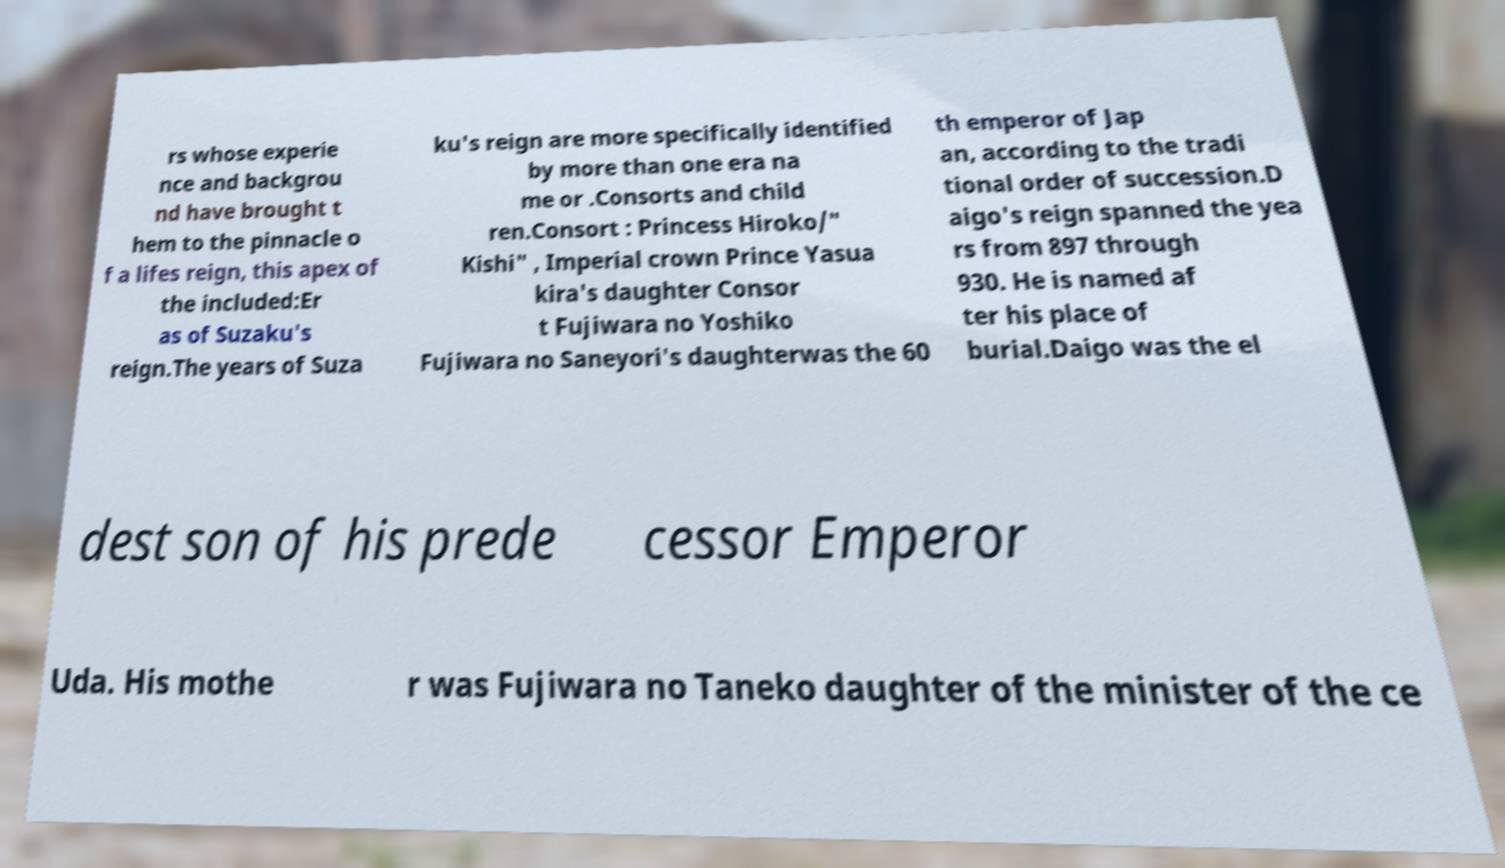Could you assist in decoding the text presented in this image and type it out clearly? rs whose experie nce and backgrou nd have brought t hem to the pinnacle o f a lifes reign, this apex of the included:Er as of Suzaku's reign.The years of Suza ku's reign are more specifically identified by more than one era na me or .Consorts and child ren.Consort : Princess Hiroko/" Kishi" , Imperial crown Prince Yasua kira's daughter Consor t Fujiwara no Yoshiko Fujiwara no Saneyori's daughterwas the 60 th emperor of Jap an, according to the tradi tional order of succession.D aigo's reign spanned the yea rs from 897 through 930. He is named af ter his place of burial.Daigo was the el dest son of his prede cessor Emperor Uda. His mothe r was Fujiwara no Taneko daughter of the minister of the ce 